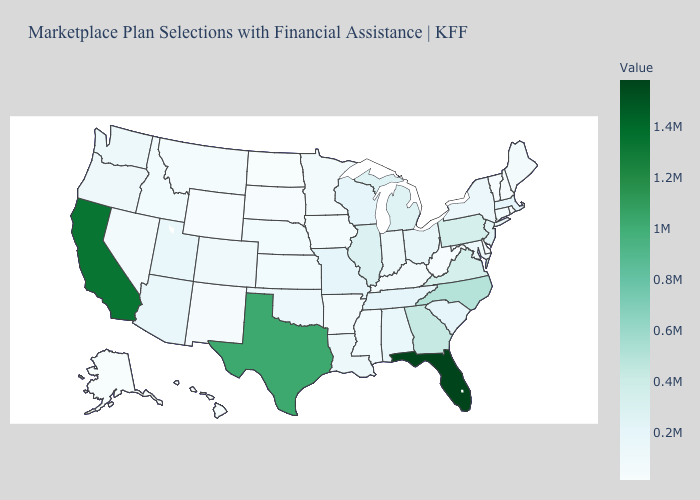Does the map have missing data?
Answer briefly. No. Does Maryland have the highest value in the South?
Give a very brief answer. No. Among the states that border North Carolina , does Tennessee have the highest value?
Give a very brief answer. No. Which states have the lowest value in the MidWest?
Write a very short answer. North Dakota. Among the states that border Tennessee , which have the lowest value?
Keep it brief. Arkansas. Among the states that border Virginia , which have the lowest value?
Give a very brief answer. West Virginia. 